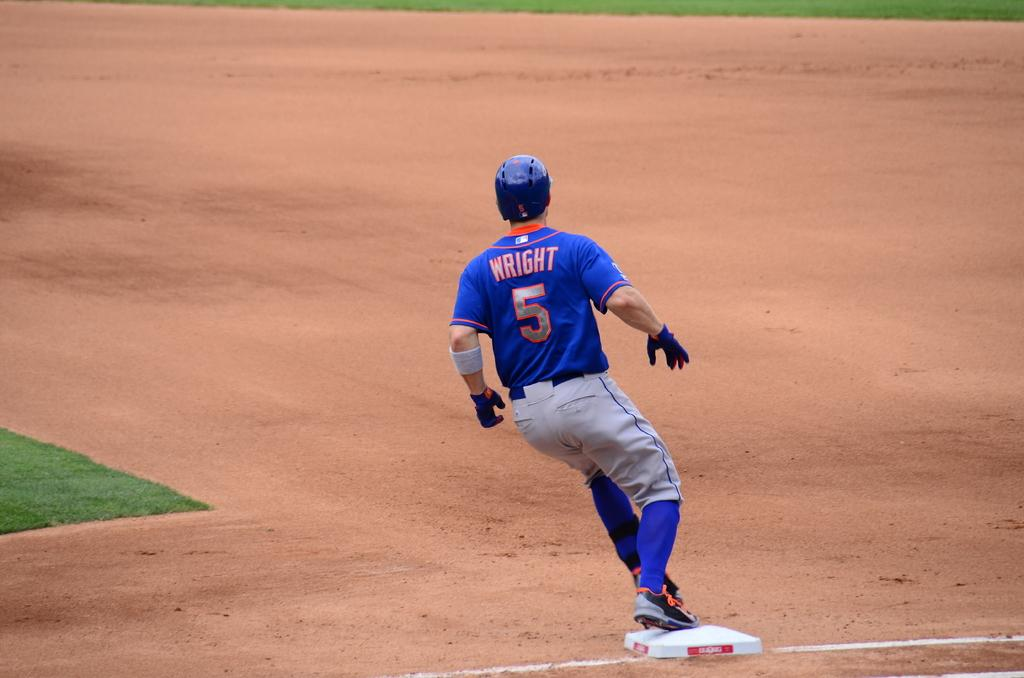Provide a one-sentence caption for the provided image. A man is wearing a blue shirt that says "WRIGHT 5" on the back. 